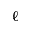<formula> <loc_0><loc_0><loc_500><loc_500>\ell</formula> 